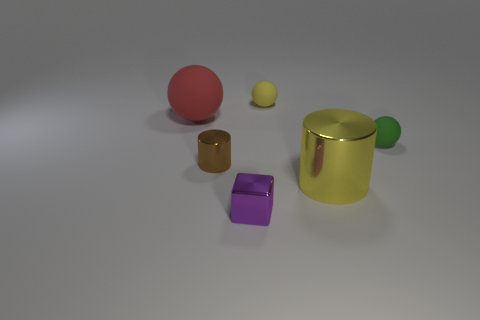The red sphere has what size?
Offer a very short reply. Large. What shape is the rubber object that is both to the left of the tiny green rubber thing and right of the big red thing?
Your answer should be very brief. Sphere. What number of purple objects are small matte objects or cubes?
Offer a terse response. 1. There is a yellow object that is on the left side of the yellow metal thing; is its size the same as the rubber ball that is left of the metallic block?
Ensure brevity in your answer.  No. What number of objects are small gray spheres or small matte spheres?
Make the answer very short. 2. Are there any tiny purple objects that have the same shape as the yellow shiny thing?
Make the answer very short. No. Is the number of gray rubber blocks less than the number of big matte balls?
Give a very brief answer. Yes. Does the big red object have the same shape as the tiny green object?
Make the answer very short. Yes. How many objects are either purple objects or matte spheres that are behind the green matte sphere?
Keep it short and to the point. 3. What number of big red spheres are there?
Your response must be concise. 1. 